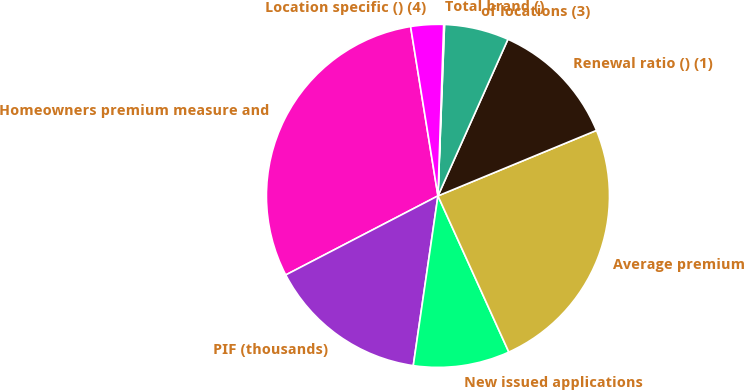<chart> <loc_0><loc_0><loc_500><loc_500><pie_chart><fcel>Homeowners premium measure and<fcel>PIF (thousands)<fcel>New issued applications<fcel>Average premium<fcel>Renewal ratio () (1)<fcel>of locations (3)<fcel>Total brand ()<fcel>Location specific () (4)<nl><fcel>30.08%<fcel>15.08%<fcel>9.08%<fcel>24.46%<fcel>12.08%<fcel>6.08%<fcel>0.08%<fcel>3.08%<nl></chart> 